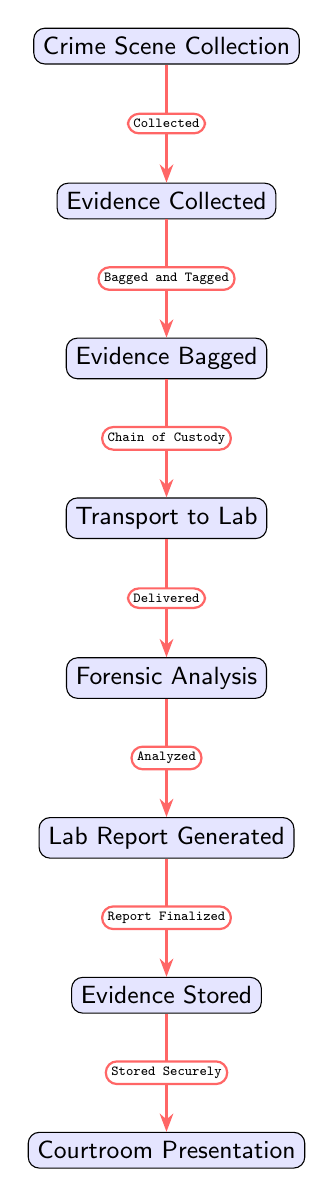What is the first step in the evidence transmission process? The first node in the diagram is "Crime Scene Collection," which signifies the beginning of the evidence transmission process.
Answer: Crime Scene Collection What happens after evidence is collected? After the evidence is collected in the "Crime Scene Collection" node, it moves to the next step, which is labeled "Evidence Collected."
Answer: Evidence Collected How many main stages are there in the transmission process? Counting from "Crime Scene Collection" to "Courtroom Presentation," there are a total of seven stages or nodes in this process.
Answer: Seven What is the relationship between "Evidence Bagged" and "Transport to Lab"? The relationship between these two nodes is represented by an arrow showing that from "Evidence Bagged," the evidence is transported to the lab, under the labeled action "Chain of Custody."
Answer: Chain of Custody What is required for evidence to be transported from the collection point to the lab? The evidence must be properly bagged and tagged, which is stated in the relationship from "Evidence Collected" to "Evidence Bagged."
Answer: Bagged and Tagged What action is taken after forensic analysis is completed? After forensic analysis is completed, a "Lab Report Generated" is created, which follows directly after the forensic analysis in the flow of the diagram.
Answer: Lab Report Generated What is the significance of "Evidence Stored" in the process? "Evidence Stored" is a crucial step that ensures that evidence remains secure and is stored away safely after the lab report has been generated, indicated by the flow from that node.
Answer: Stored Securely How does the flow of evidence continue from "Lab Report Generated"? Once the lab report is generated, the flow continues to "Evidence Stored," indicating that the evidence as well as the report must be securely stored after finalization of analysis.
Answer: Evidence Stored What indicates the final step in the evidence transmission process? The last node in the diagram, "Courtroom Presentation," indicates the final step in the transmission process, illustrating the conclusion of the evidence handling.
Answer: Courtroom Presentation 